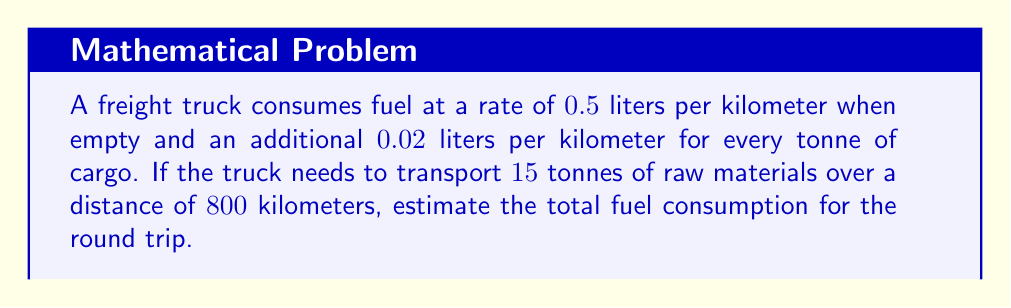What is the answer to this math problem? Let's break this down step-by-step:

1) First, calculate the fuel consumption rate for the loaded truck:
   Base rate: $0.5$ L/km
   Additional rate: $0.02$ L/km/tonne × $15$ tonnes = $0.3$ L/km
   Total rate: $0.5 + 0.3 = 0.8$ L/km

2) Calculate fuel consumption for one-way trip:
   $$0.8 \text{ L/km} × 800 \text{ km} = 640 \text{ L}$$

3) For the return trip, the truck will be empty, so we use the base rate:
   $$0.5 \text{ L/km} × 800 \text{ km} = 400 \text{ L}$$

4) Sum up the fuel consumption for both trips:
   $$640 \text{ L} + 400 \text{ L} = 1040 \text{ L}$$

Therefore, the total fuel consumption for the round trip is $1040$ liters.
Answer: 1040 L 